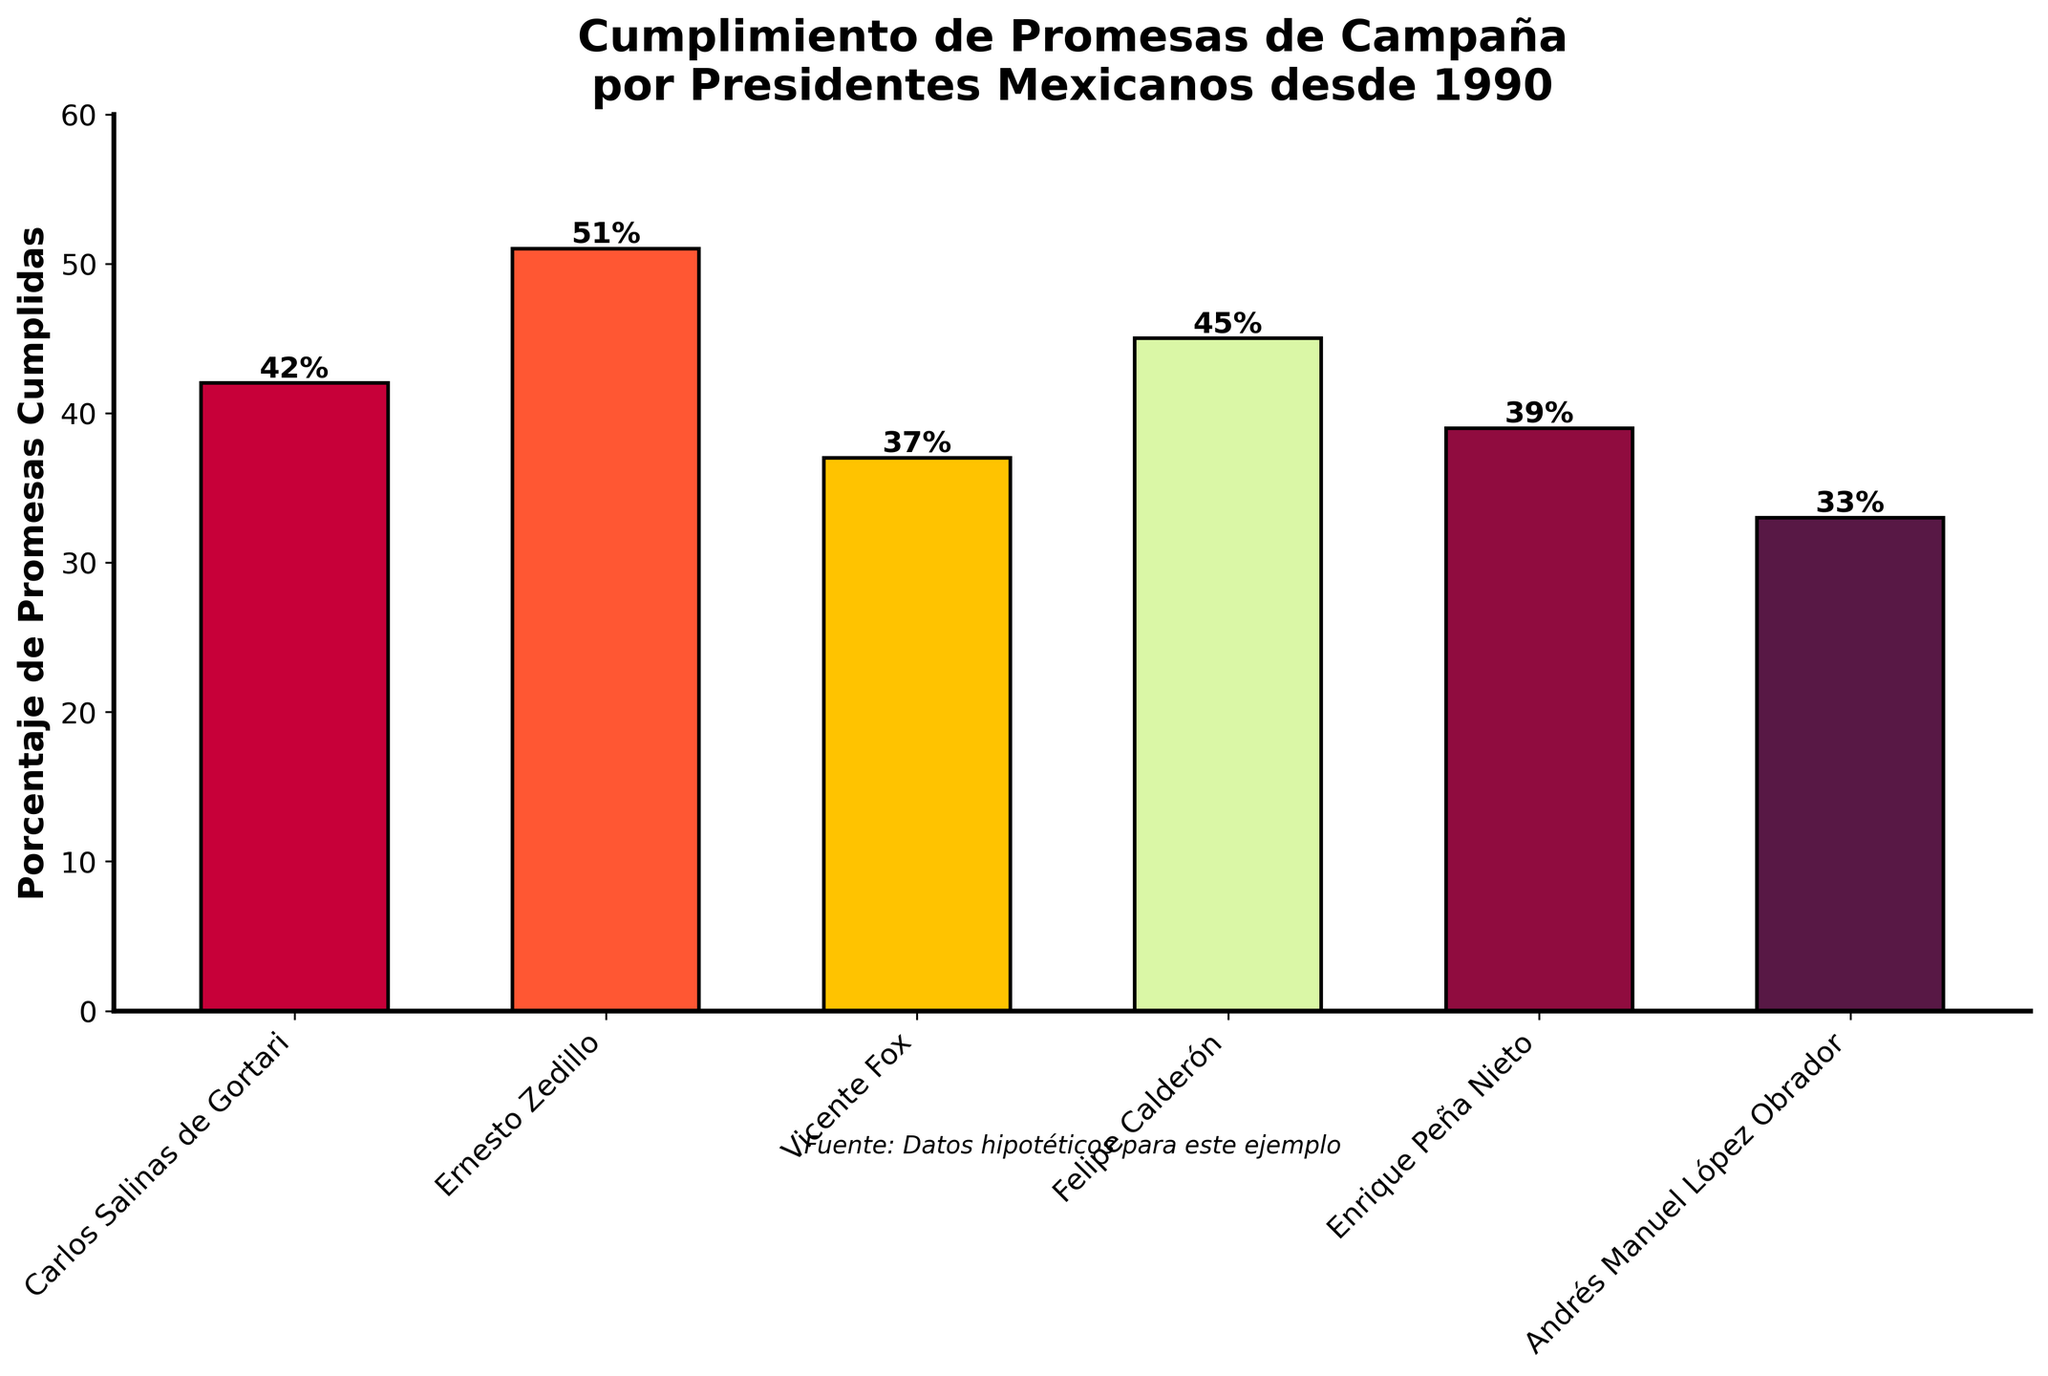Which president fulfilled the highest percentage of campaign promises? Ernesto Zedillo has the highest bar in the chart, which indicates that he fulfilled the highest percentage of campaign promises.
Answer: Ernesto Zedillo What is the average percentage of promises fulfilled across all presidents? Add up the percentages for all presidents and then divide by the number of presidents: (42 + 51 + 37 + 45 + 39 + 33) / 6 = 247 / 6 = 41.17
Answer: 41.17 How many presidents fulfilled less than 40% of their campaign promises? Look at the bars below the 40% mark: Vicente Fox (37%), Enrique Peña Nieto (39%), and Andrés Manuel López Obrador (33%). Three presidents fulfilled less than 40% of their promises.
Answer: 3 Which president fulfilled campaign promises more than 45% after Carlos Salinas de Gortari? Ernesto Zedillo is the only president who fulfilled more than 45% of campaign promises after Carlos Salinas de Gortari, as his percentage is higher than 45%.
Answer: Ernesto Zedillo Compare the percentage of promises fulfilled by Felipe Calderón and Enrique Peña Nieto. Who fulfilled more? Felipe Calderón has a higher bar (45%) compared to Enrique Peña Nieto (39%). Thus, Felipe Calderón fulfilled more promises.
Answer: Felipe Calderón What is the difference in the percentage of promises fulfilled between Vicente Fox and the president with the lowest percentage? Vicente Fox fulfilled 37% and Andrés Manuel López Obrador fulfilled 33%. The difference is 37 - 33 = 4.
Answer: 4 Identify the presidents who fulfilled promises within 40% and 50%. The bars within the range 40% to 50% belong to Carlos Salinas de Gortari (42%), Felipe Calderón (45%), and Enrique Peña Nieto (39%). But Enrique Peña Nieto is below 40%. Hence, Carlos Salinas de Gortari and Felipe Calderón fulfilled promises within 40% and 50%.
Answer: Carlos Salinas de Gortari, Felipe Calderón What is the total percentage of promises fulfilled by the presidents named Ernesto Zedillo and Andrés Manuel López Obrador? Add the percentages for Ernesto Zedillo (51%) and Andrés Manuel López Obrador (33%): 51 + 33 = 84
Answer: 84 Which two presidents have their bars colored in shades of red? The two bars colored in shades of red are for Carlos Salinas de Gortari and Andrés Manuel López Obrador.
Answer: Carlos Salinas de Gortari, Andrés Manuel López Obrador 